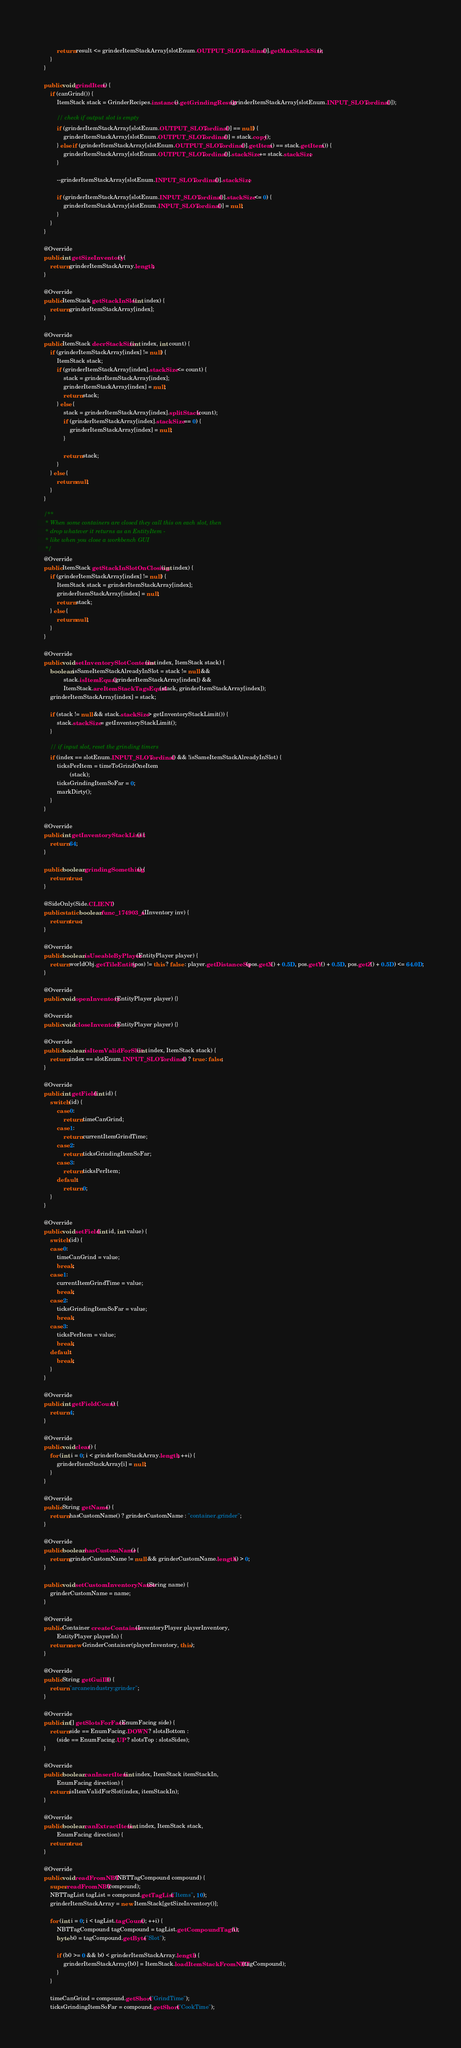Convert code to text. <code><loc_0><loc_0><loc_500><loc_500><_Java_>			
			return result <= grinderItemStackArray[slotEnum.OUTPUT_SLOT.ordinal()].getMaxStackSize();
		}
	}
	
	public void grindItem() {
		if (canGrind()) {
			ItemStack stack = GrinderRecipes.instance().getGrindingResult(grinderItemStackArray[slotEnum.INPUT_SLOT.ordinal()]);
			
			// check if output slot is empty
			if (grinderItemStackArray[slotEnum.OUTPUT_SLOT.ordinal()] == null) {
				grinderItemStackArray[slotEnum.OUTPUT_SLOT.ordinal()] = stack.copy();
			} else if (grinderItemStackArray[slotEnum.OUTPUT_SLOT.ordinal()].getItem() == stack.getItem()) {
				grinderItemStackArray[slotEnum.OUTPUT_SLOT.ordinal()].stackSize += stack.stackSize;
			}
			
			--grinderItemStackArray[slotEnum.INPUT_SLOT.ordinal()].stackSize;
			
			if (grinderItemStackArray[slotEnum.INPUT_SLOT.ordinal()].stackSize <= 0) {
				grinderItemStackArray[slotEnum.INPUT_SLOT.ordinal()] = null;
			}
		}
	}

	@Override
	public int getSizeInventory() {
		return grinderItemStackArray.length;
	}

	@Override
	public ItemStack getStackInSlot(int index) {
		return grinderItemStackArray[index];
	}

	@Override
	public ItemStack decrStackSize(int index, int count) {
		if (grinderItemStackArray[index] != null) {
			ItemStack stack;
			if (grinderItemStackArray[index].stackSize <= count) {
				stack = grinderItemStackArray[index];
				grinderItemStackArray[index] = null;
				return stack;
			} else {
				stack = grinderItemStackArray[index].splitStack(count);
				if (grinderItemStackArray[index].stackSize == 0) {
					grinderItemStackArray[index] = null;
				}
				
				return stack;
			}
		} else {
			return null;
		}
	}

	/**
	 * When some containers are closed they call this on each slot, then
	 * drop whatever it returns as an EntityItem -
	 * like when you close a workbench GUI
	 */
	@Override
	public ItemStack getStackInSlotOnClosing(int index) {
		if (grinderItemStackArray[index] != null) {
			ItemStack stack = grinderItemStackArray[index];
			grinderItemStackArray[index] = null;
			return stack;
		} else {
			return null;
		}
	}

	@Override
	public void setInventorySlotContents(int index, ItemStack stack) {
		boolean isSameItemStackAlreadyInSlot = stack != null &&
				stack.isItemEqual(grinderItemStackArray[index]) &&
				ItemStack.areItemStackTagsEqual(stack, grinderItemStackArray[index]);
		grinderItemStackArray[index] = stack;
		
		if (stack != null && stack.stackSize > getInventoryStackLimit()) {
			stack.stackSize = getInventoryStackLimit();
		}
		
		// if input slot, reset the grinding timers
		if (index == slotEnum.INPUT_SLOT.ordinal() && !isSameItemStackAlreadyInSlot) {
			ticksPerItem = timeToGrindOneItem
					(stack);
			ticksGrindingItemSoFar = 0;
			markDirty();
		}
	}

	@Override
	public int getInventoryStackLimit() {
		return 64;
	}
	
	public boolean grindingSomething() {
		return true;
	}
	
	@SideOnly(Side.CLIENT)
	public static boolean func_174903_a(IInventory inv) {
		return true;
	}

	@Override
	public boolean isUseableByPlayer(EntityPlayer player) {
		return worldObj.getTileEntity(pos) != this ? false : player.getDistanceSq(pos.getX() + 0.5D, pos.getY() + 0.5D, pos.getZ() + 0.5D) <= 64.0D;
	}

	@Override
	public void openInventory(EntityPlayer player) {}

	@Override
	public void closeInventory(EntityPlayer player) {}

	@Override
	public boolean isItemValidForSlot(int index, ItemStack stack) {
		return index == slotEnum.INPUT_SLOT.ordinal() ? true : false;
	}

	@Override
	public int getField(int id) {
		switch (id) {
			case 0:
				return timeCanGrind;
			case 1:
				return currentItemGrindTime;
			case 2:
				return ticksGrindingItemSoFar;
			case 3:
				return ticksPerItem;
			default:
				return 0;
		}
	}

	@Override
	public void setField(int id, int value) {
		switch (id) {
		case 0:
			timeCanGrind = value;
			break;
		case 1:
			currentItemGrindTime = value;
			break;
		case 2:
			ticksGrindingItemSoFar = value;
			break;
		case 3:
			ticksPerItem = value;
			break;
		default:
			break;
		}
	}

	@Override
	public int getFieldCount() {
		return 4;
	}

	@Override
	public void clear() {
		for (int i = 0; i < grinderItemStackArray.length; ++i) {
			grinderItemStackArray[i] = null;
		}
	}

	@Override
	public String getName() {
		return hasCustomName() ? grinderCustomName : "container.grinder";
	}

	@Override
	public boolean hasCustomName() {
		return grinderCustomName != null && grinderCustomName.length() > 0;
	}
	
	public void setCustomInventoryName(String name) {
		grinderCustomName = name;
	}

	@Override
	public Container createContainer(InventoryPlayer playerInventory,
			EntityPlayer playerIn) {
		return new GrinderContainer(playerInventory, this);
	}

	@Override
	public String getGuiID() {
		return "arcaneindustry:grinder";
	}

	@Override
	public int[] getSlotsForFace(EnumFacing side) {
		return side == EnumFacing.DOWN ? slotsBottom :
			(side == EnumFacing.UP ? slotsTop : slotsSides);
	}

	@Override
	public boolean canInsertItem(int index, ItemStack itemStackIn,
			EnumFacing direction) {
		return isItemValidForSlot(index, itemStackIn);
	}

	@Override
	public boolean canExtractItem(int index, ItemStack stack,
			EnumFacing direction) {
		return true;
	}
	
	@Override
	public void readFromNBT(NBTTagCompound compound) {
		super.readFromNBT(compound);
		NBTTagList tagList = compound.getTagList("Items", 10);
		grinderItemStackArray = new ItemStack[getSizeInventory()];
		
		for (int i = 0; i < tagList.tagCount(); ++i) {
			NBTTagCompound tagCompound = tagList.getCompoundTagAt(i);
			byte b0 = tagCompound.getByte("Slot");
			
			if (b0 >= 0 && b0 < grinderItemStackArray.length) {
				grinderItemStackArray[b0] = ItemStack.loadItemStackFromNBT(tagCompound);
			}
		}
		
		timeCanGrind = compound.getShort("GrindTime");
		ticksGrindingItemSoFar = compound.getShort("CookTime");</code> 